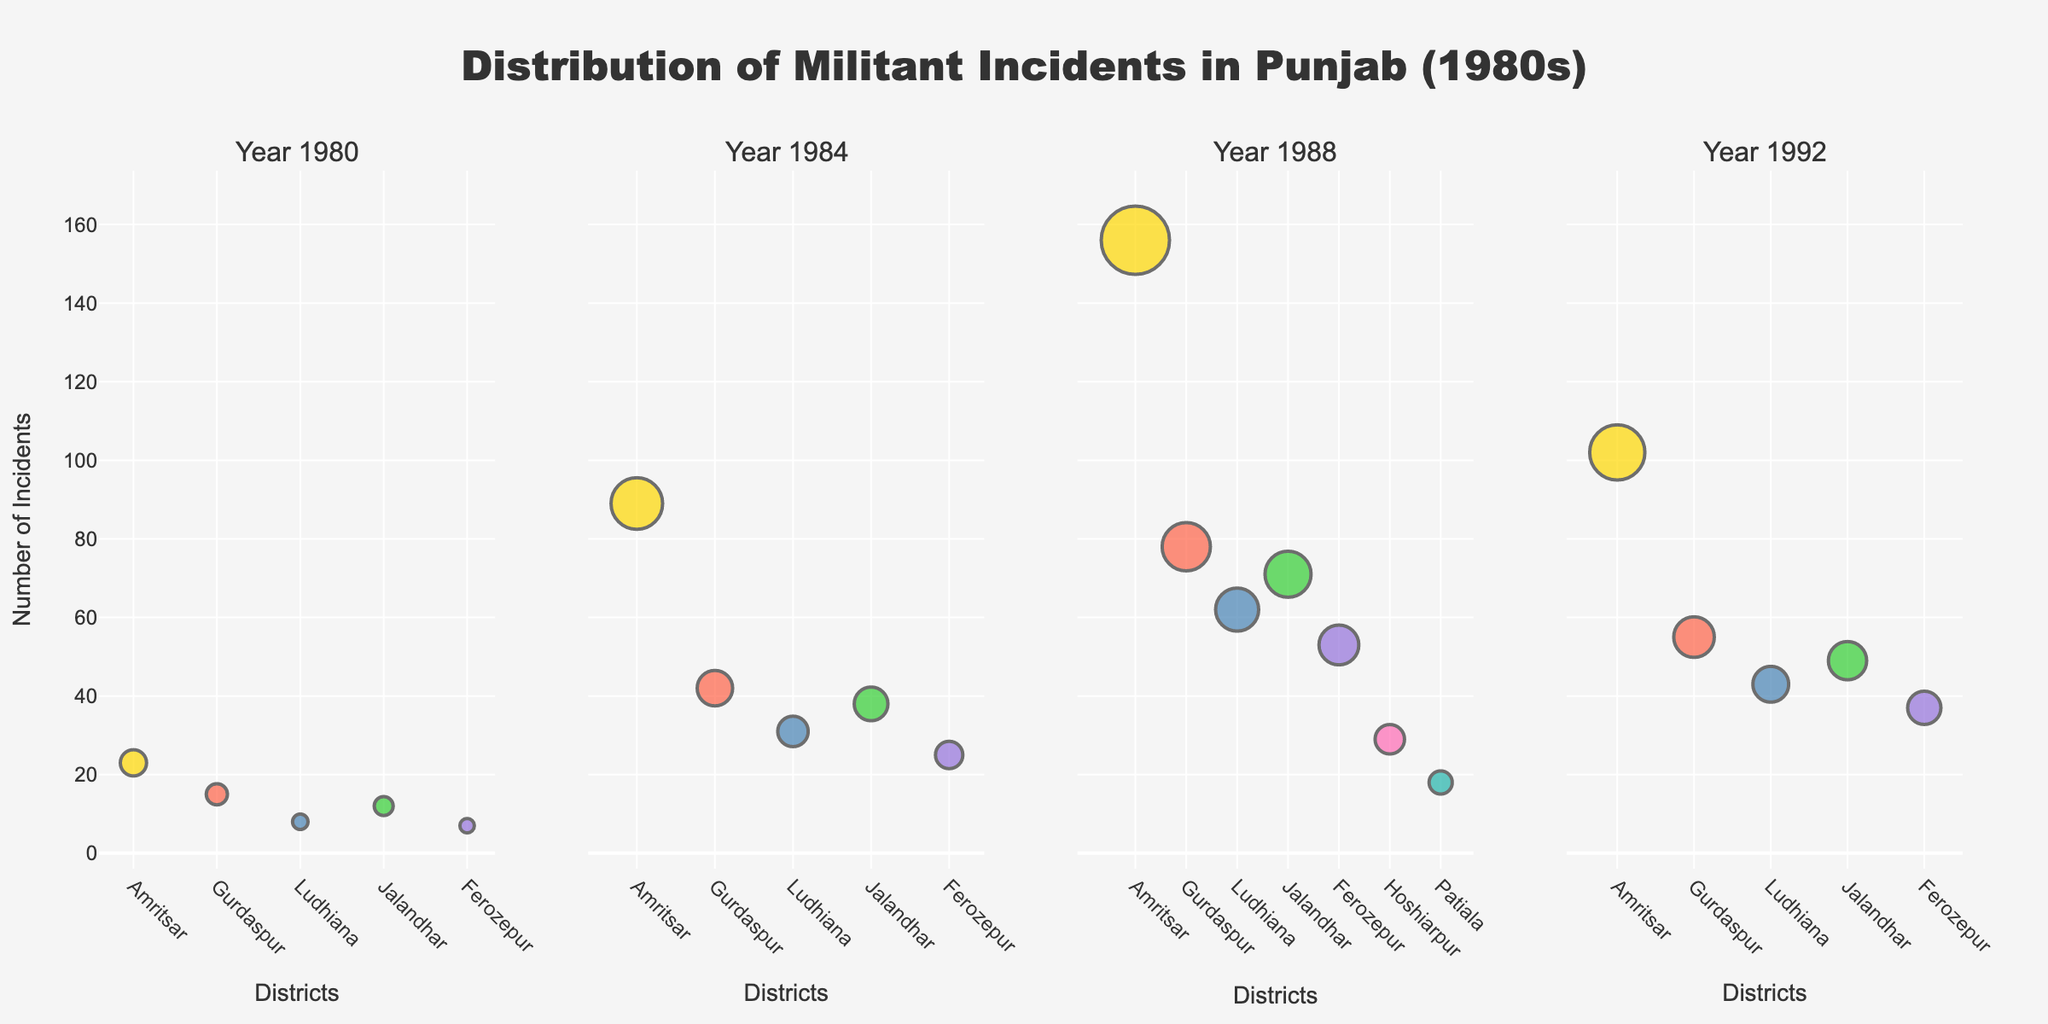What is the title of the plot? The title is prominently displayed at the top of the figure. Most figures with clear labeling will have a title to describe what the plot represents.
Answer: Distribution of Militant Incidents in Punjab (1980s) Which district had the highest number of incidents in 1980? To find this, we look at the subplot for the year 1980 and identify the largest bubble by size. The hover text can also provide this detail.
Answer: Amritsar How many incidents were reported in Ludhiana in 1988? Refer to the subplot for the year 1988 and locate the bubble representing Ludhiana. The hover text or the bubble's details will show the number of incidents.
Answer: 62 What is the overall trend of incidents in Amritsar from 1980 to 1992? Look at the subplots for each year and locate Amritsar. Track the size of bubbles corresponding to Amritsar across 1980, 1984, 1988, and 1992 to observe any increases or decreases.
Answer: Increasing and then slightly decreasing Which year had the highest number of total incidents across all districts? For this, we need to sum up the incident numbers for each year and compare.
Answer: 1988 Compare the number of incidents in Gurdaspur between 1984 and 1992? Look at the subplots to find the bubbles for Gurdaspur for these two years. Compare the sizes or check the hover text for the number of incidents.
Answer: 42 in 1984 and 55 in 1992 Which districts were included in the plot for the year 1988 but not for the year 1980? Compare the districts listed in the subplots for 1980 and 1988 to see which ones are unique to 1988.
Answer: Hoshiarpur and Patiala What is the average number of incidents reported in Ferozepur across all the years? Sum the number of incidents in Ferozepur for each year and divide by the number of years (4). Sum: 7+25+53+37 = 122, then 122/4
Answer: 30.5 Which district showed the least variation in the number of incidents over the years? Analyze the changes in the sizes of bubbles representing each district across the years. The district with the most consistent bubble size has the least variation.
Answer: Ferozepur In 1992, how many more incidents were reported in Amritsar compared to Patiala? Look at the subplot for 1992 and note the number of incidents for Amritsar and Patiala, then subtract the latter from the former. 102 - 18 = 84
Answer: 84 